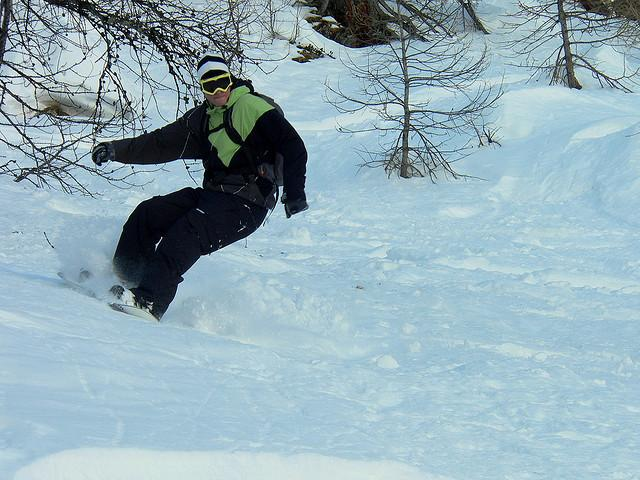What is the man wearing? goggles 